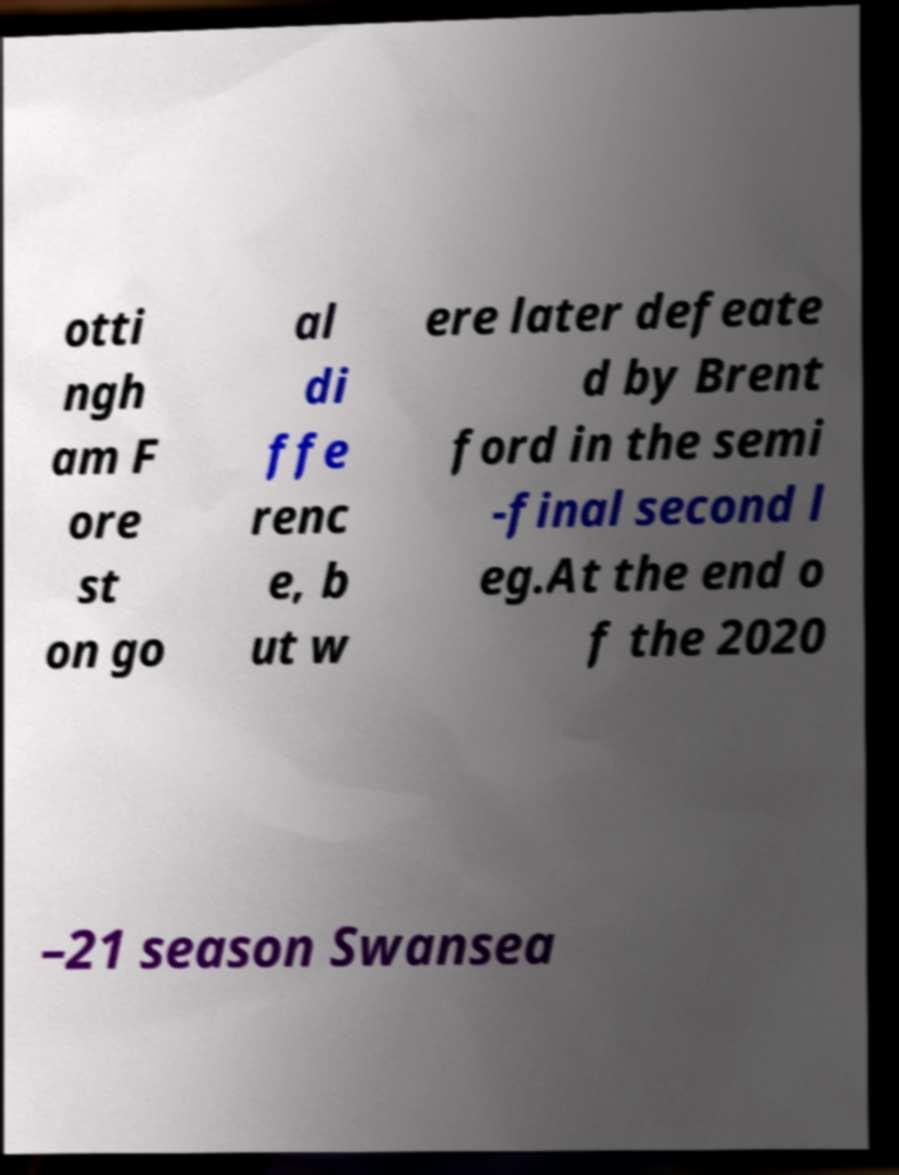What messages or text are displayed in this image? I need them in a readable, typed format. otti ngh am F ore st on go al di ffe renc e, b ut w ere later defeate d by Brent ford in the semi -final second l eg.At the end o f the 2020 –21 season Swansea 